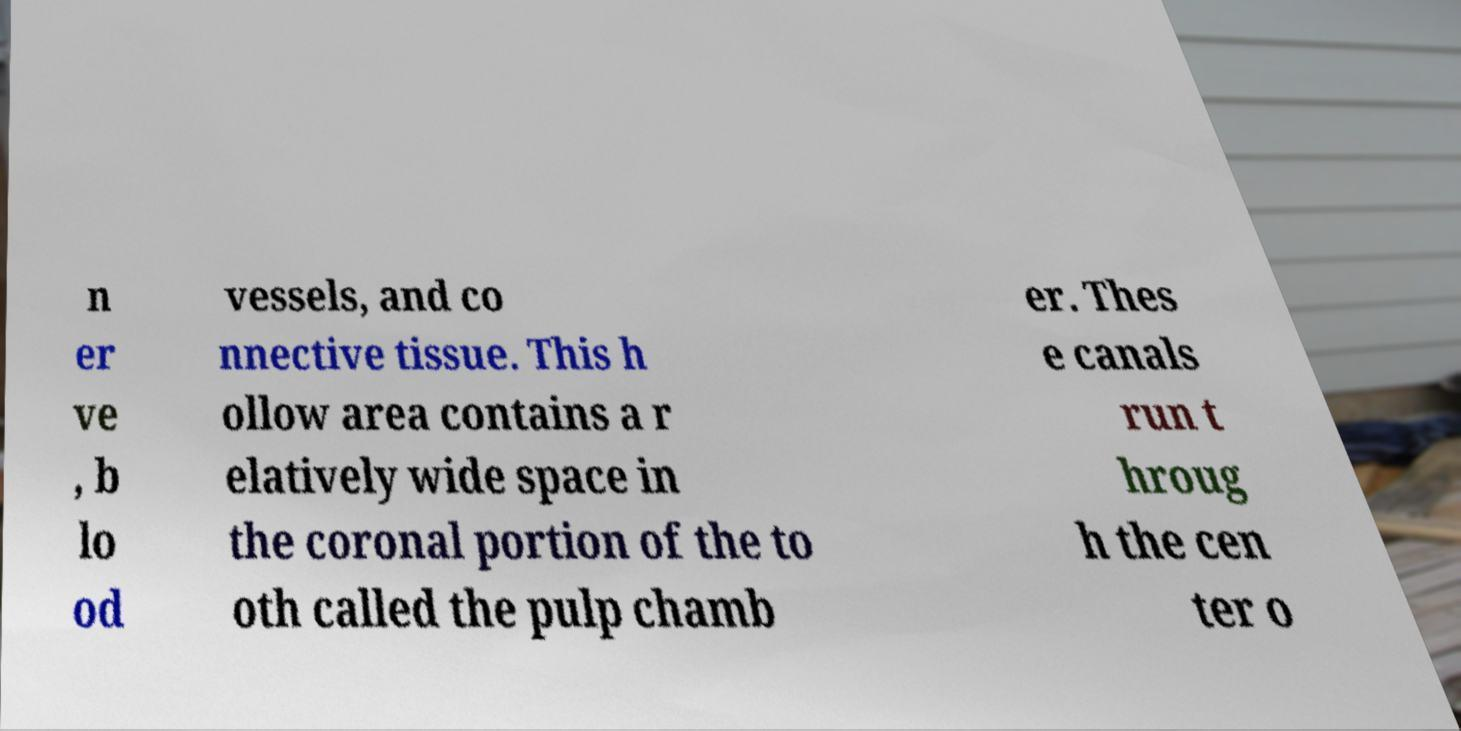I need the written content from this picture converted into text. Can you do that? n er ve , b lo od vessels, and co nnective tissue. This h ollow area contains a r elatively wide space in the coronal portion of the to oth called the pulp chamb er. Thes e canals run t hroug h the cen ter o 